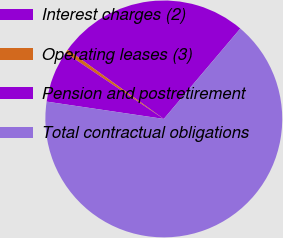Convert chart to OTSL. <chart><loc_0><loc_0><loc_500><loc_500><pie_chart><fcel>Interest charges (2)<fcel>Operating leases (3)<fcel>Pension and postretirement<fcel>Total contractual obligations<nl><fcel>26.24%<fcel>0.52%<fcel>7.08%<fcel>66.15%<nl></chart> 